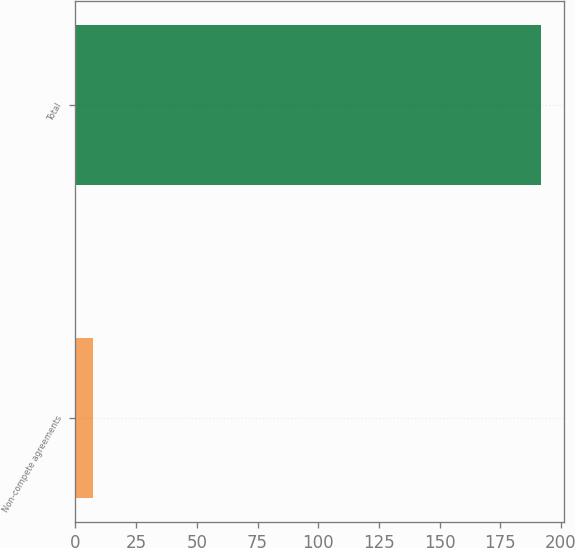<chart> <loc_0><loc_0><loc_500><loc_500><bar_chart><fcel>Non-compete agreements<fcel>Total<nl><fcel>7.2<fcel>191.6<nl></chart> 